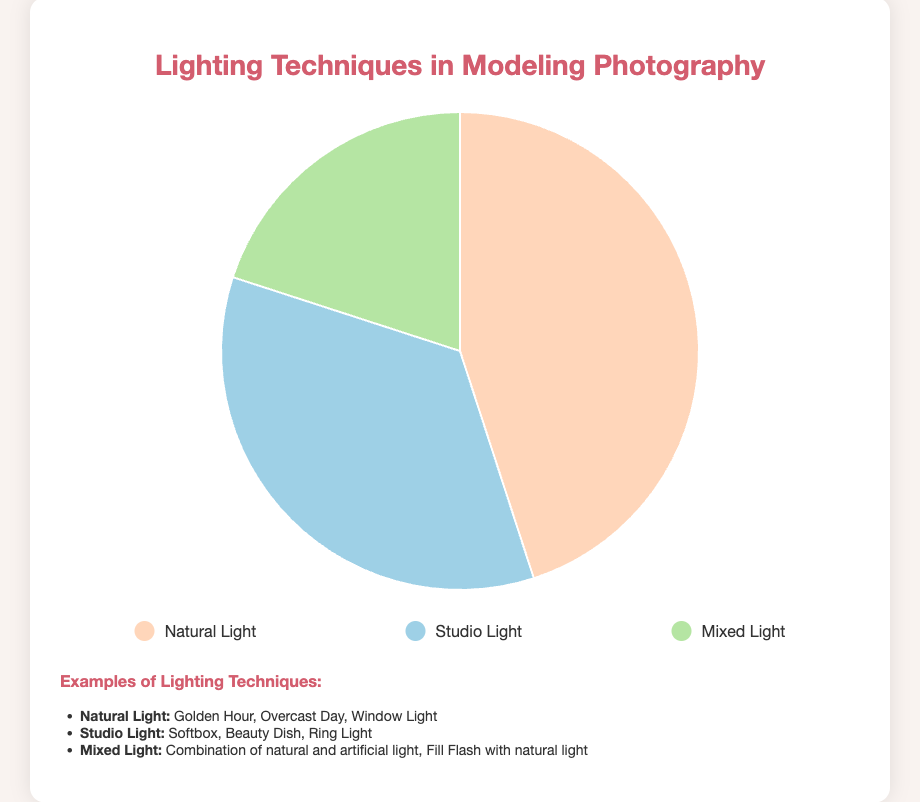What percentage of lighting techniques used in modeling photography is Studio Light? The pie chart data indicates that Studio Light accounts for 35% of the lighting techniques used in modeling photography.
Answer: 35% What is the difference in percentage between Natural Light and Mixed Light? Natural Light represents 45% and Mixed Light represents 20%. The difference is 45% - 20% = 25%.
Answer: 25% Which lighting technique has the smallest usage percentage? The pie chart shows that Mixed Light has the smallest percentage at 20% compared to Natural Light and Studio Light.
Answer: Mixed Light What is the combined percentage of Natural Light and Studio Light? Natural Light accounts for 45% and Studio Light accounts for 35%. The combined percentage is 45% + 35% = 80%.
Answer: 80% Are there more examples listed for Natural Light or Studio Light? The bulleted examples provided under "Natural Light" and "Studio Light" need to be counted. Natural Light has 3 examples (Golden Hour, Overcast Day, Window Light) and Studio Light also has 3 examples (Softbox, Beauty Dish, Ring Light). They are equal.
Answer: Equal Which technique is used more, Natural Light or Studio Light? And by how much? Natural Light is used more with 45% compared to Studio Light with 35%. The difference is 45% - 35% = 10%.
Answer: Natural Light by 10% If you combine the percentage of Mixed Light and Studio Light, is it more than Natural Light? The combined percentage of Mixed Light (20%) and Studio Light (35%) is 20% + 35% = 55%, which is more than Natural Light at 45%.
Answer: Yes What color is used to represent Natural Light in the pie chart? The chart shows Natural Light is represented with a light orange color in the pie chart.
Answer: Light orange What is the average percentage of the three lighting techniques? The total percentage is the sum of the three types: 45% (Natural Light) + 35% (Studio Light) + 20% (Mixed Light) = 100%. The average is 100% / 3 ≈ 33.33%.
Answer: 33.33% Compare the percentages of Natural Light and Studio Light. Which is greater and by how much? Natural Light is 45% and Studio Light is 35%. Natural Light is greater by 45% - 35% = 10%.
Answer: Natural Light by 10% 